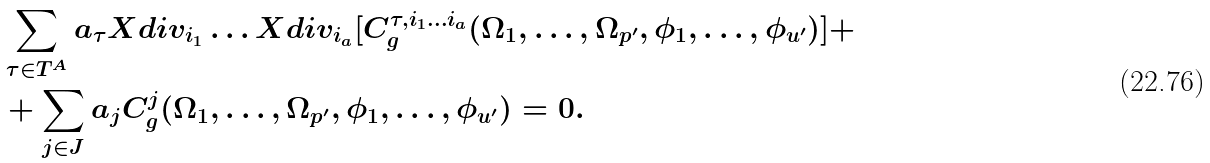Convert formula to latex. <formula><loc_0><loc_0><loc_500><loc_500>& \sum _ { \tau \in T ^ { A } } a _ { \tau } X d i v _ { i _ { 1 } } \dots X d i v _ { i _ { a } } [ C ^ { \tau , i _ { 1 } \dots i _ { a } } _ { g } ( \Omega _ { 1 } , \dots , \Omega _ { p ^ { \prime } } , \phi _ { 1 } , \dots , \phi _ { u ^ { \prime } } ) ] + \\ & + \sum _ { j \in J } a _ { j } C ^ { j } _ { g } ( \Omega _ { 1 } , \dots , \Omega _ { p ^ { \prime } } , \phi _ { 1 } , \dots , \phi _ { u ^ { \prime } } ) = 0 .</formula> 